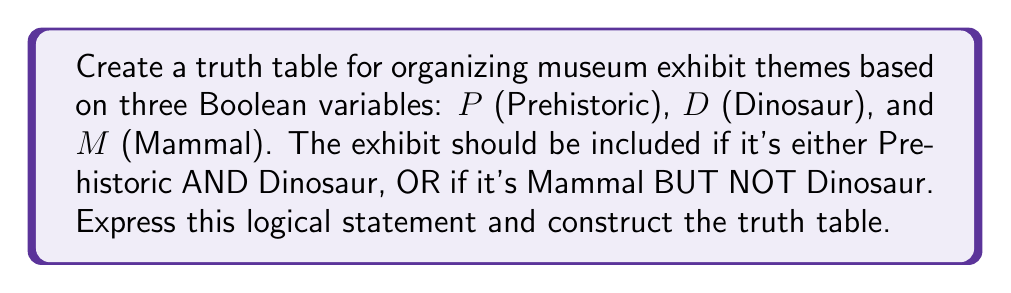Help me with this question. Let's approach this step-by-step:

1. First, we need to express the logical statement:
   $$(P \land D) \lor (M \land \lnot D)$$

2. Now, let's create the truth table. We'll need 8 rows (2^3) to cover all possible combinations of P, D, and M.

3. Fill in the truth values for P, D, and M:
   $$\begin{array}{|c|c|c|c|c|c|}
   \hline
   P & D & M & P \land D & M \land \lnot D & (P \land D) \lor (M \land \lnot D) \\
   \hline
   0 & 0 & 0 & & & \\
   0 & 0 & 1 & & & \\
   0 & 1 & 0 & & & \\
   0 & 1 & 1 & & & \\
   1 & 0 & 0 & & & \\
   1 & 0 & 1 & & & \\
   1 & 1 & 0 & & & \\
   1 & 1 & 1 & & & \\
   \hline
   \end{array}$$

4. Calculate $P \land D$:
   $$\begin{array}{|c|c|c|c|c|c|}
   \hline
   P & D & M & P \land D & M \land \lnot D & (P \land D) \lor (M \land \lnot D) \\
   \hline
   0 & 0 & 0 & 0 & & \\
   0 & 0 & 1 & 0 & & \\
   0 & 1 & 0 & 0 & & \\
   0 & 1 & 1 & 0 & & \\
   1 & 0 & 0 & 0 & & \\
   1 & 0 & 1 & 0 & & \\
   1 & 1 & 0 & 1 & & \\
   1 & 1 & 1 & 1 & & \\
   \hline
   \end{array}$$

5. Calculate $M \land \lnot D$:
   $$\begin{array}{|c|c|c|c|c|c|}
   \hline
   P & D & M & P \land D & M \land \lnot D & (P \land D) \lor (M \land \lnot D) \\
   \hline
   0 & 0 & 0 & 0 & 0 & \\
   0 & 0 & 1 & 0 & 1 & \\
   0 & 1 & 0 & 0 & 0 & \\
   0 & 1 & 1 & 0 & 0 & \\
   1 & 0 & 0 & 0 & 0 & \\
   1 & 0 & 1 & 0 & 1 & \\
   1 & 1 & 0 & 1 & 0 & \\
   1 & 1 & 1 & 1 & 0 & \\
   \hline
   \end{array}$$

6. Finally, calculate $(P \land D) \lor (M \land \lnot D)$:
   $$\begin{array}{|c|c|c|c|c|c|}
   \hline
   P & D & M & P \land D & M \land \lnot D & (P \land D) \lor (M \land \lnot D) \\
   \hline
   0 & 0 & 0 & 0 & 0 & 0 \\
   0 & 0 & 1 & 0 & 1 & 1 \\
   0 & 1 & 0 & 0 & 0 & 0 \\
   0 & 1 & 1 & 0 & 0 & 0 \\
   1 & 0 & 0 & 0 & 0 & 0 \\
   1 & 0 & 1 & 0 & 1 & 1 \\
   1 & 1 & 0 & 1 & 0 & 1 \\
   1 & 1 & 1 & 1 & 0 & 1 \\
   \hline
   \end{array}$$

This completed truth table shows when an exhibit should be included based on the given criteria.
Answer: $$(P \land D) \lor (M \land \lnot D)$$
$$\begin{array}{|c|c|c|c|}
\hline
P & D & M & \text{Include} \\
\hline
0 & 0 & 0 & 0 \\
0 & 0 & 1 & 1 \\
0 & 1 & 0 & 0 \\
0 & 1 & 1 & 0 \\
1 & 0 & 0 & 0 \\
1 & 0 & 1 & 1 \\
1 & 1 & 0 & 1 \\
1 & 1 & 1 & 1 \\
\hline
\end{array}$$ 